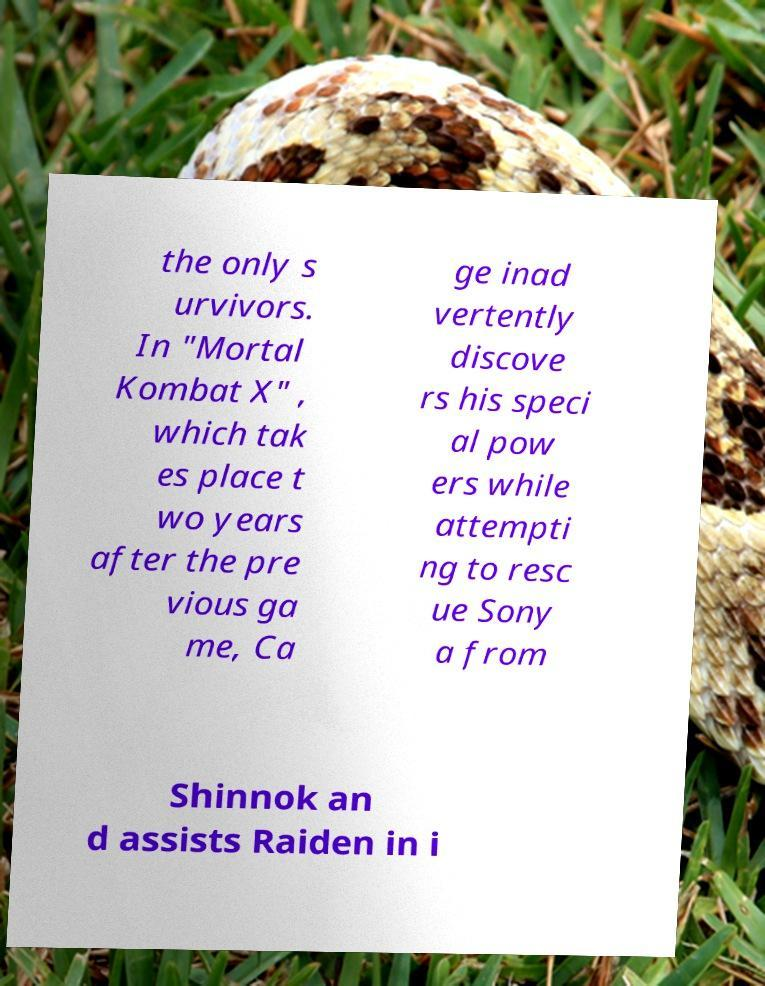I need the written content from this picture converted into text. Can you do that? the only s urvivors. In "Mortal Kombat X" , which tak es place t wo years after the pre vious ga me, Ca ge inad vertently discove rs his speci al pow ers while attempti ng to resc ue Sony a from Shinnok an d assists Raiden in i 